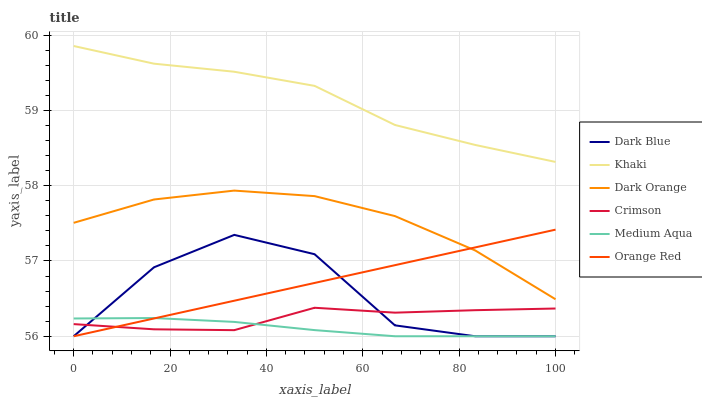Does Medium Aqua have the minimum area under the curve?
Answer yes or no. Yes. Does Khaki have the maximum area under the curve?
Answer yes or no. Yes. Does Dark Blue have the minimum area under the curve?
Answer yes or no. No. Does Dark Blue have the maximum area under the curve?
Answer yes or no. No. Is Orange Red the smoothest?
Answer yes or no. Yes. Is Dark Blue the roughest?
Answer yes or no. Yes. Is Khaki the smoothest?
Answer yes or no. No. Is Khaki the roughest?
Answer yes or no. No. Does Dark Blue have the lowest value?
Answer yes or no. Yes. Does Khaki have the lowest value?
Answer yes or no. No. Does Khaki have the highest value?
Answer yes or no. Yes. Does Dark Blue have the highest value?
Answer yes or no. No. Is Medium Aqua less than Dark Orange?
Answer yes or no. Yes. Is Khaki greater than Crimson?
Answer yes or no. Yes. Does Crimson intersect Orange Red?
Answer yes or no. Yes. Is Crimson less than Orange Red?
Answer yes or no. No. Is Crimson greater than Orange Red?
Answer yes or no. No. Does Medium Aqua intersect Dark Orange?
Answer yes or no. No. 